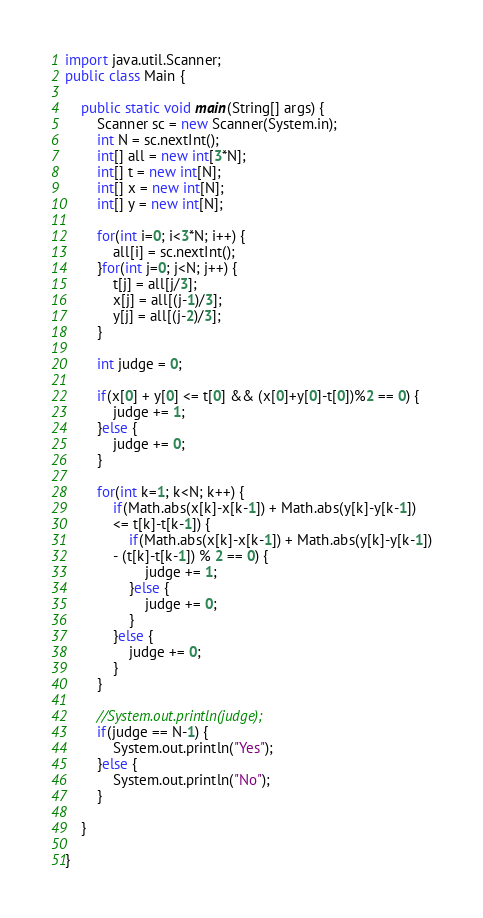<code> <loc_0><loc_0><loc_500><loc_500><_Java_>import java.util.Scanner;
public class Main {

	public static void main(String[] args) {
		Scanner sc = new Scanner(System.in);
		int N = sc.nextInt();
		int[] all = new int[3*N];
		int[] t = new int[N];
		int[] x = new int[N];
		int[] y = new int[N];

		for(int i=0; i<3*N; i++) {
			all[i] = sc.nextInt();
		}for(int j=0; j<N; j++) {
			t[j] = all[j/3];
			x[j] = all[(j-1)/3];
			y[j] = all[(j-2)/3];
		}

		int judge = 0;

		if(x[0] + y[0] <= t[0] && (x[0]+y[0]-t[0])%2 == 0) {
			judge += 1;
		}else {
			judge += 0;
		}

		for(int k=1; k<N; k++) {
			if(Math.abs(x[k]-x[k-1]) + Math.abs(y[k]-y[k-1])
			<= t[k]-t[k-1]) {
				if(Math.abs(x[k]-x[k-1]) + Math.abs(y[k]-y[k-1])
			- (t[k]-t[k-1]) % 2 == 0) {
					judge += 1;
				}else {
					judge += 0;
				}
			}else {
				judge += 0;
			}
		}

		//System.out.println(judge);
		if(judge == N-1) {
			System.out.println("Yes");
		}else {
			System.out.println("No");
		}

	}

}
</code> 